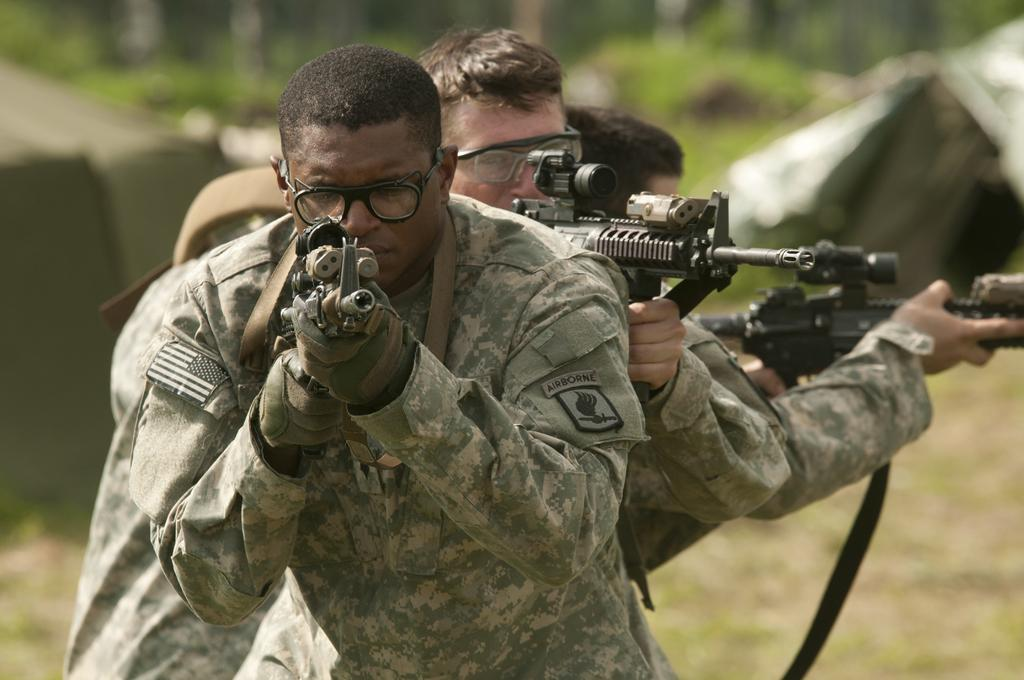Who or what is present in the image? A: There are people in the image. What are the people wearing on their faces? The people are wearing goggles. What are the people holding in their hands? The people are holding guns. What position are the people in? The people are standing. What are the people wearing on their hands? The people are wearing gloves. What type of shelter can be seen in the image? There are tents in the image. What type of natural environment is visible in the background? There is grass in the background of the image. How is the background of the image depicted? The background is blurred. Can you see the moon in the image? No, the moon is not visible in the image. Are there any visitors present in the image? There is no mention of visitors in the image; it only shows people wearing goggles, holding guns, and standing. 